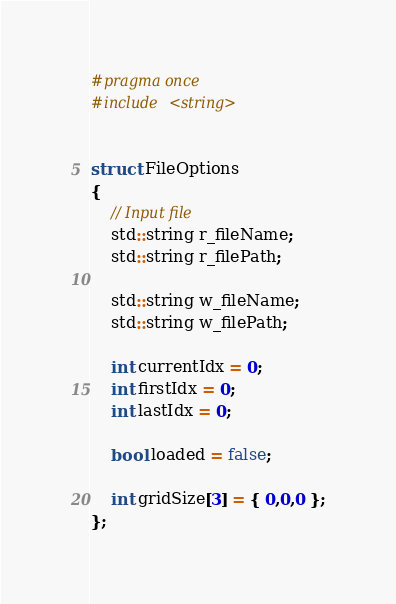<code> <loc_0><loc_0><loc_500><loc_500><_C_>#pragma once
#include <string>


struct FileOptions
{
	// Input file
	std::string r_fileName;
	std::string r_filePath;
	
	std::string w_fileName;
	std::string w_filePath;

	int currentIdx = 0;
	int firstIdx = 0;
	int lastIdx = 0;

	bool loaded = false;

	int gridSize[3] = { 0,0,0 };
};</code> 